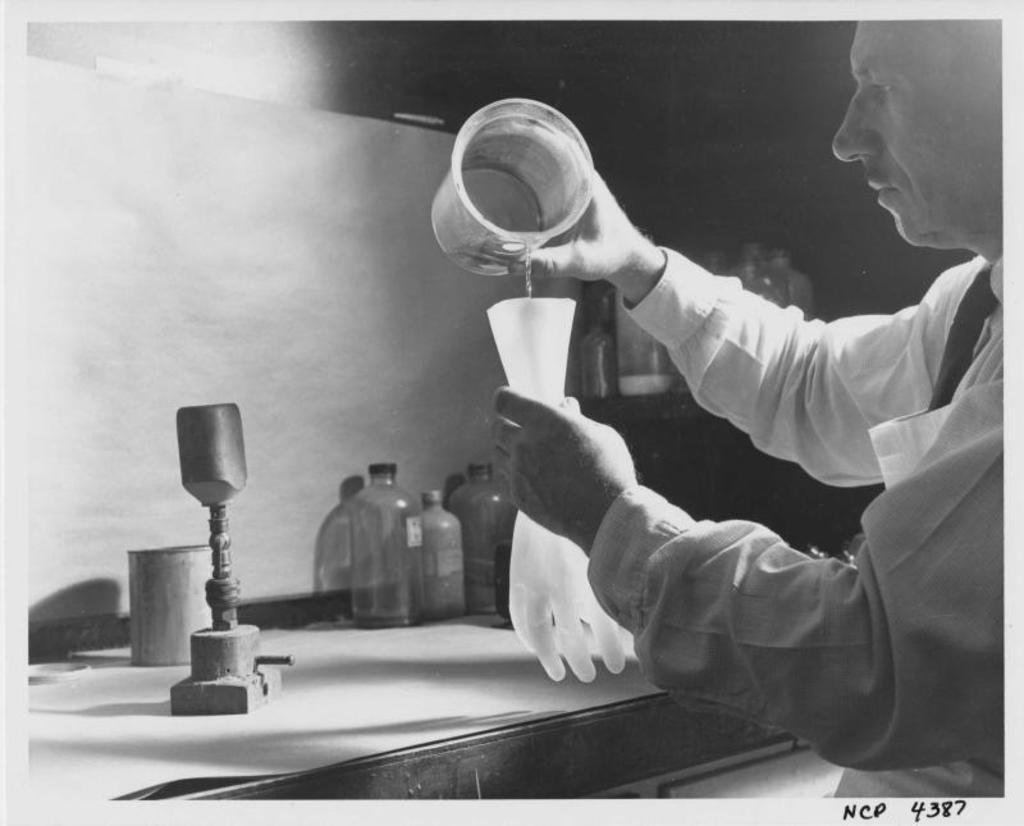What is the person in the image holding? The person is holding a glove and a jug of water. What else can be seen in the image besides the person? There are bottles in the background of the image, a wooden stand placed on a table, and a wall visible in the image. What type of jellyfish can be seen swimming in the water in the image? There is no jellyfish present in the image; it features a person holding a glove and a jug of water, along with other items mentioned. 